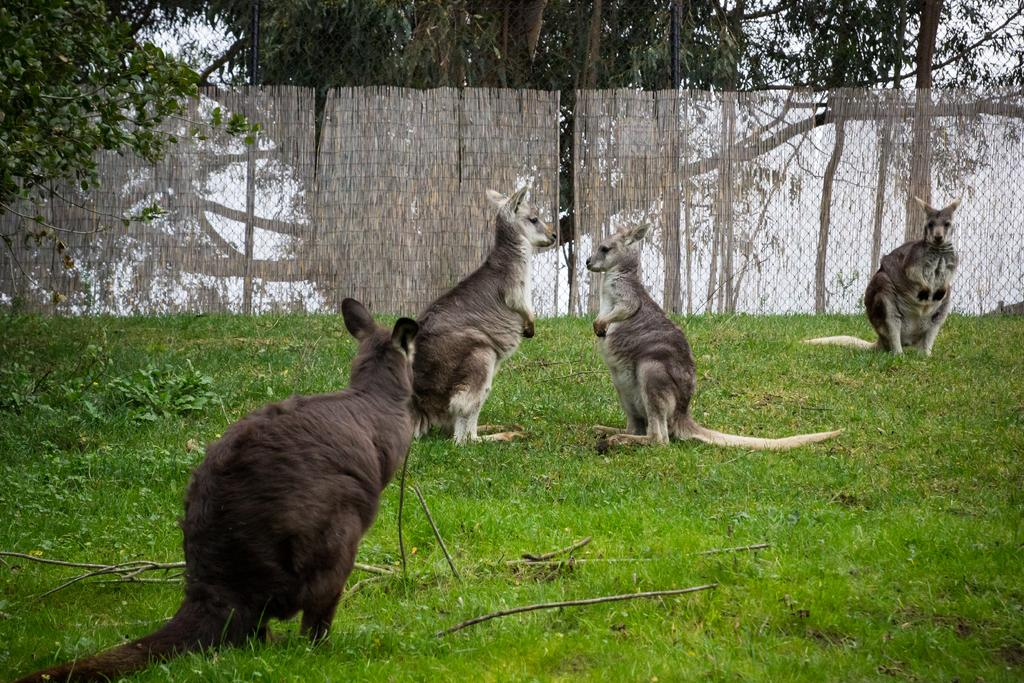What animals can be seen in the image? There are kangaroos in the image. What type of terrain is visible in the image? There is grass on the floor in the image. What architectural feature is present in the background of the image? There is a fence in the background of the image. What type of vegetation is present in the image? There is a tree in the image. What is the condition of the sky in the image? The sky is clear in the image. What type of division is being performed by the kangaroos in the image? There is no division being performed by the kangaroos in the image; they are simply standing or moving around. Can you see any fingers in the image? There are no fingers visible in the image, as it features kangaroos and natural elements. What type of kettle is present in the image? There is no kettle present in the image; it features kangaroos, grass, a fence, a tree, and a clear sky. 